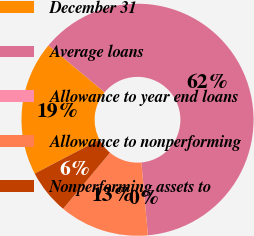<chart> <loc_0><loc_0><loc_500><loc_500><pie_chart><fcel>December 31<fcel>Average loans<fcel>Allowance to year end loans<fcel>Allowance to nonperforming<fcel>Nonperforming assets to<nl><fcel>18.75%<fcel>62.49%<fcel>0.0%<fcel>12.5%<fcel>6.25%<nl></chart> 